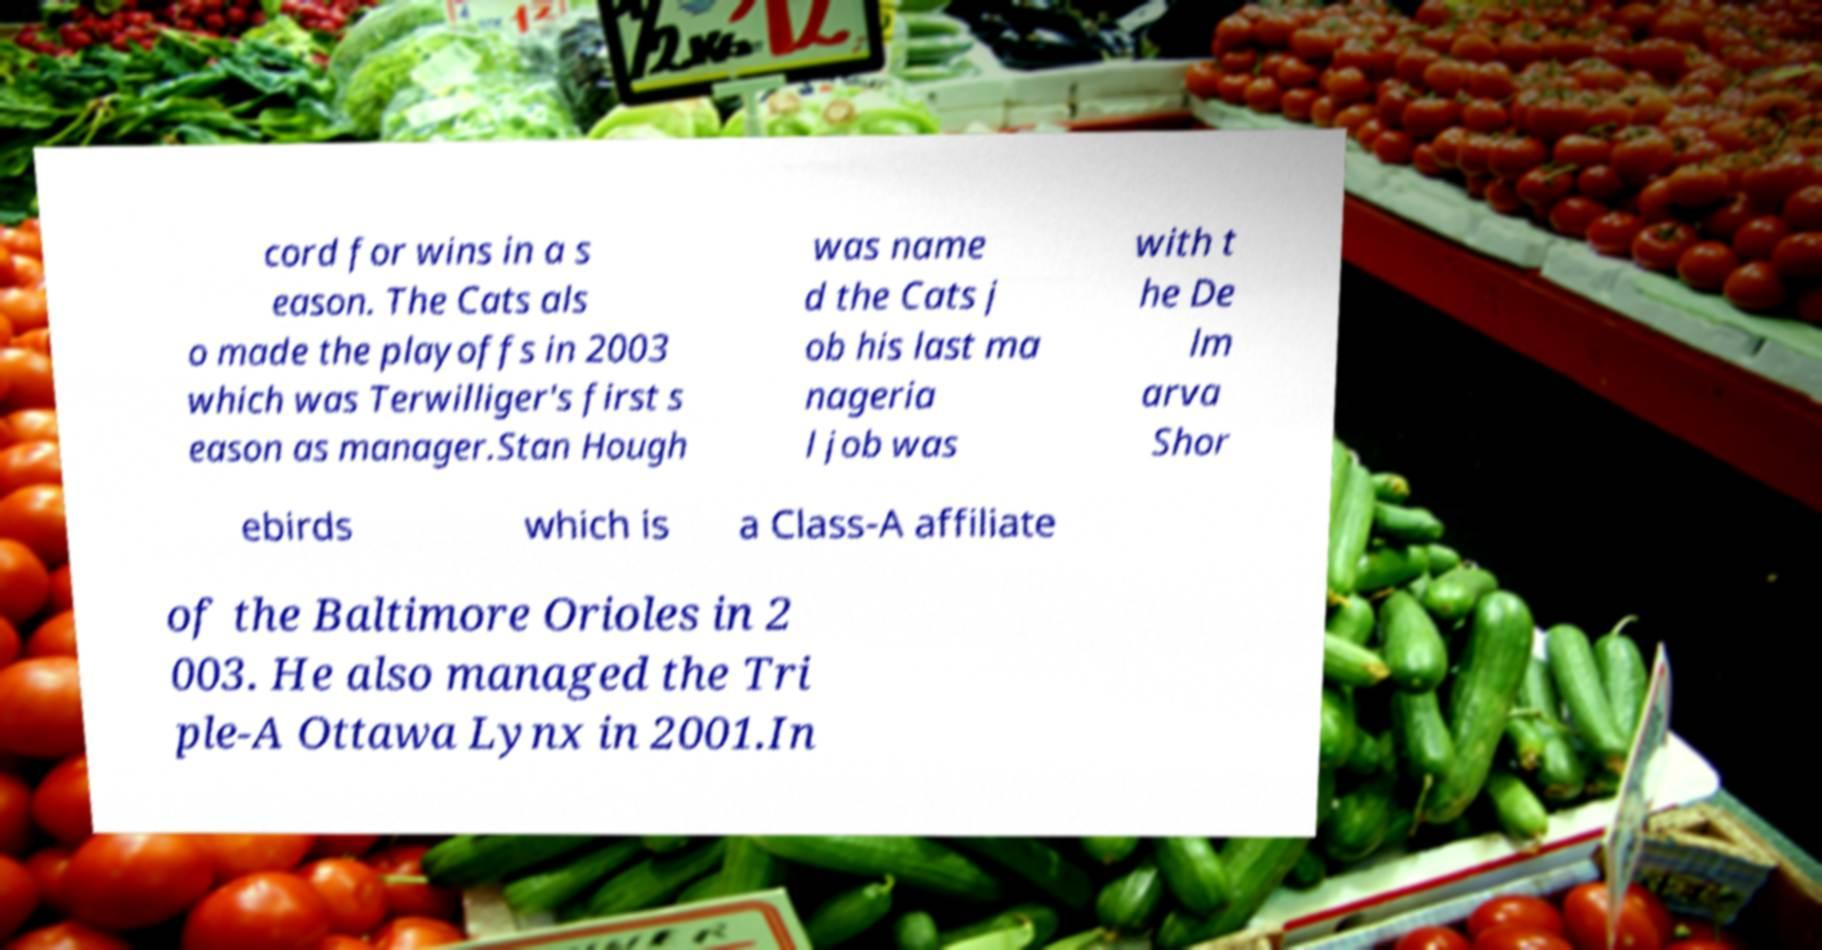Can you accurately transcribe the text from the provided image for me? cord for wins in a s eason. The Cats als o made the playoffs in 2003 which was Terwilliger's first s eason as manager.Stan Hough was name d the Cats j ob his last ma nageria l job was with t he De lm arva Shor ebirds which is a Class-A affiliate of the Baltimore Orioles in 2 003. He also managed the Tri ple-A Ottawa Lynx in 2001.In 